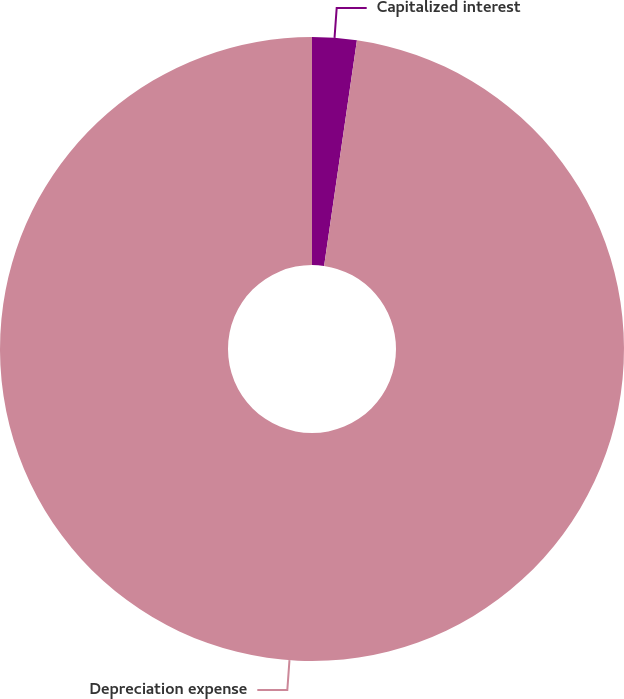<chart> <loc_0><loc_0><loc_500><loc_500><pie_chart><fcel>Capitalized interest<fcel>Depreciation expense<nl><fcel>2.3%<fcel>97.7%<nl></chart> 